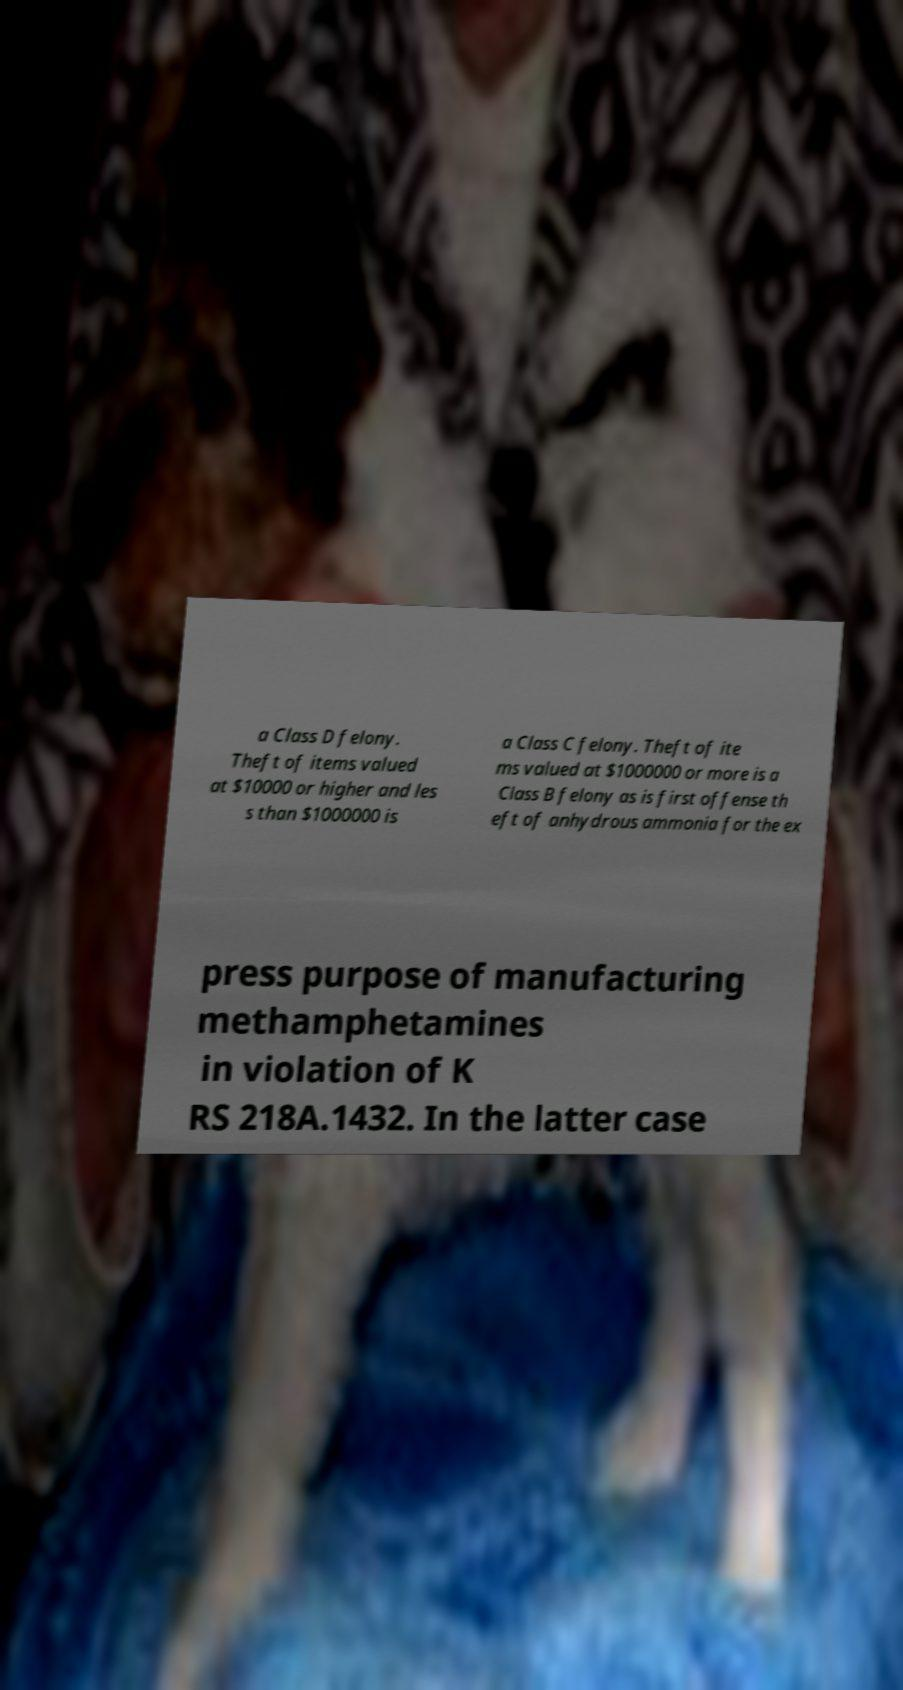For documentation purposes, I need the text within this image transcribed. Could you provide that? a Class D felony. Theft of items valued at $10000 or higher and les s than $1000000 is a Class C felony. Theft of ite ms valued at $1000000 or more is a Class B felony as is first offense th eft of anhydrous ammonia for the ex press purpose of manufacturing methamphetamines in violation of K RS 218A.1432. In the latter case 